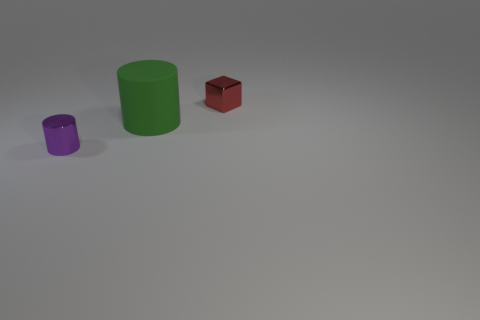The small thing in front of the red shiny cube that is behind the green cylinder that is in front of the shiny cube is what color?
Provide a succinct answer. Purple. Are there any other things that have the same color as the big rubber thing?
Provide a succinct answer. No. What size is the metallic object that is in front of the small red object?
Keep it short and to the point. Small. There is a shiny thing that is the same size as the metallic cylinder; what shape is it?
Your answer should be compact. Cube. Are the small object right of the big green matte cylinder and the cylinder that is in front of the green matte cylinder made of the same material?
Make the answer very short. Yes. What is the material of the cylinder behind the metallic thing that is on the left side of the green cylinder?
Offer a very short reply. Rubber. What size is the shiny object that is to the right of the small metal object that is to the left of the small object that is behind the tiny purple thing?
Make the answer very short. Small. Is the size of the purple metallic cylinder the same as the green cylinder?
Offer a terse response. No. There is a object that is on the right side of the green rubber cylinder; is it the same shape as the thing to the left of the big cylinder?
Your answer should be compact. No. There is a tiny thing in front of the large green rubber object; are there any red metallic objects that are in front of it?
Offer a terse response. No. 